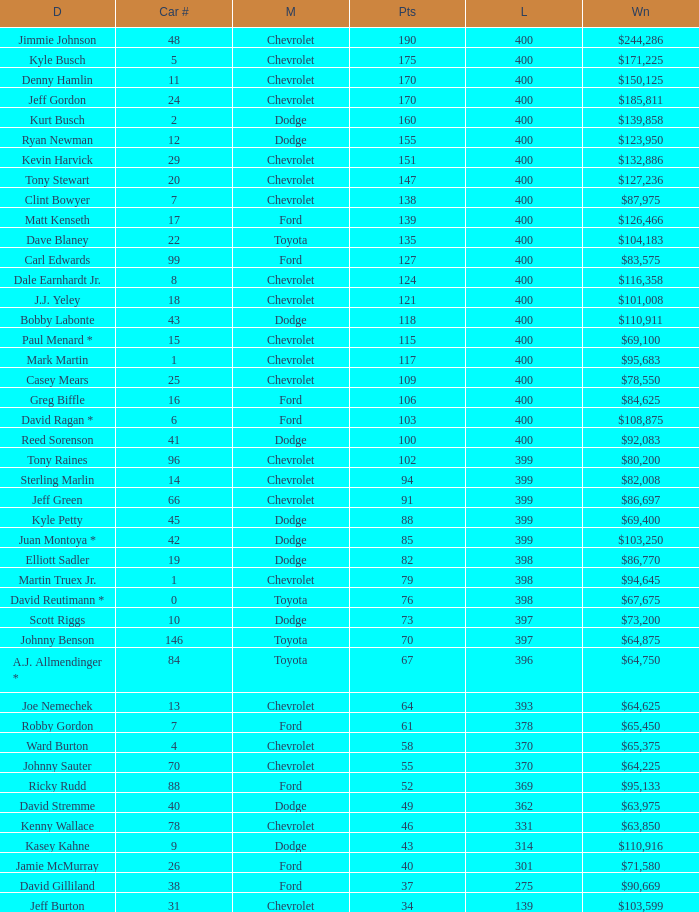What is the make of car 31? Chevrolet. Give me the full table as a dictionary. {'header': ['D', 'Car #', 'M', 'Pts', 'L', 'Wn'], 'rows': [['Jimmie Johnson', '48', 'Chevrolet', '190', '400', '$244,286'], ['Kyle Busch', '5', 'Chevrolet', '175', '400', '$171,225'], ['Denny Hamlin', '11', 'Chevrolet', '170', '400', '$150,125'], ['Jeff Gordon', '24', 'Chevrolet', '170', '400', '$185,811'], ['Kurt Busch', '2', 'Dodge', '160', '400', '$139,858'], ['Ryan Newman', '12', 'Dodge', '155', '400', '$123,950'], ['Kevin Harvick', '29', 'Chevrolet', '151', '400', '$132,886'], ['Tony Stewart', '20', 'Chevrolet', '147', '400', '$127,236'], ['Clint Bowyer', '7', 'Chevrolet', '138', '400', '$87,975'], ['Matt Kenseth', '17', 'Ford', '139', '400', '$126,466'], ['Dave Blaney', '22', 'Toyota', '135', '400', '$104,183'], ['Carl Edwards', '99', 'Ford', '127', '400', '$83,575'], ['Dale Earnhardt Jr.', '8', 'Chevrolet', '124', '400', '$116,358'], ['J.J. Yeley', '18', 'Chevrolet', '121', '400', '$101,008'], ['Bobby Labonte', '43', 'Dodge', '118', '400', '$110,911'], ['Paul Menard *', '15', 'Chevrolet', '115', '400', '$69,100'], ['Mark Martin', '1', 'Chevrolet', '117', '400', '$95,683'], ['Casey Mears', '25', 'Chevrolet', '109', '400', '$78,550'], ['Greg Biffle', '16', 'Ford', '106', '400', '$84,625'], ['David Ragan *', '6', 'Ford', '103', '400', '$108,875'], ['Reed Sorenson', '41', 'Dodge', '100', '400', '$92,083'], ['Tony Raines', '96', 'Chevrolet', '102', '399', '$80,200'], ['Sterling Marlin', '14', 'Chevrolet', '94', '399', '$82,008'], ['Jeff Green', '66', 'Chevrolet', '91', '399', '$86,697'], ['Kyle Petty', '45', 'Dodge', '88', '399', '$69,400'], ['Juan Montoya *', '42', 'Dodge', '85', '399', '$103,250'], ['Elliott Sadler', '19', 'Dodge', '82', '398', '$86,770'], ['Martin Truex Jr.', '1', 'Chevrolet', '79', '398', '$94,645'], ['David Reutimann *', '0', 'Toyota', '76', '398', '$67,675'], ['Scott Riggs', '10', 'Dodge', '73', '397', '$73,200'], ['Johnny Benson', '146', 'Toyota', '70', '397', '$64,875'], ['A.J. Allmendinger *', '84', 'Toyota', '67', '396', '$64,750'], ['Joe Nemechek', '13', 'Chevrolet', '64', '393', '$64,625'], ['Robby Gordon', '7', 'Ford', '61', '378', '$65,450'], ['Ward Burton', '4', 'Chevrolet', '58', '370', '$65,375'], ['Johnny Sauter', '70', 'Chevrolet', '55', '370', '$64,225'], ['Ricky Rudd', '88', 'Ford', '52', '369', '$95,133'], ['David Stremme', '40', 'Dodge', '49', '362', '$63,975'], ['Kenny Wallace', '78', 'Chevrolet', '46', '331', '$63,850'], ['Kasey Kahne', '9', 'Dodge', '43', '314', '$110,916'], ['Jamie McMurray', '26', 'Ford', '40', '301', '$71,580'], ['David Gilliland', '38', 'Ford', '37', '275', '$90,669'], ['Jeff Burton', '31', 'Chevrolet', '34', '139', '$103,599']]} 